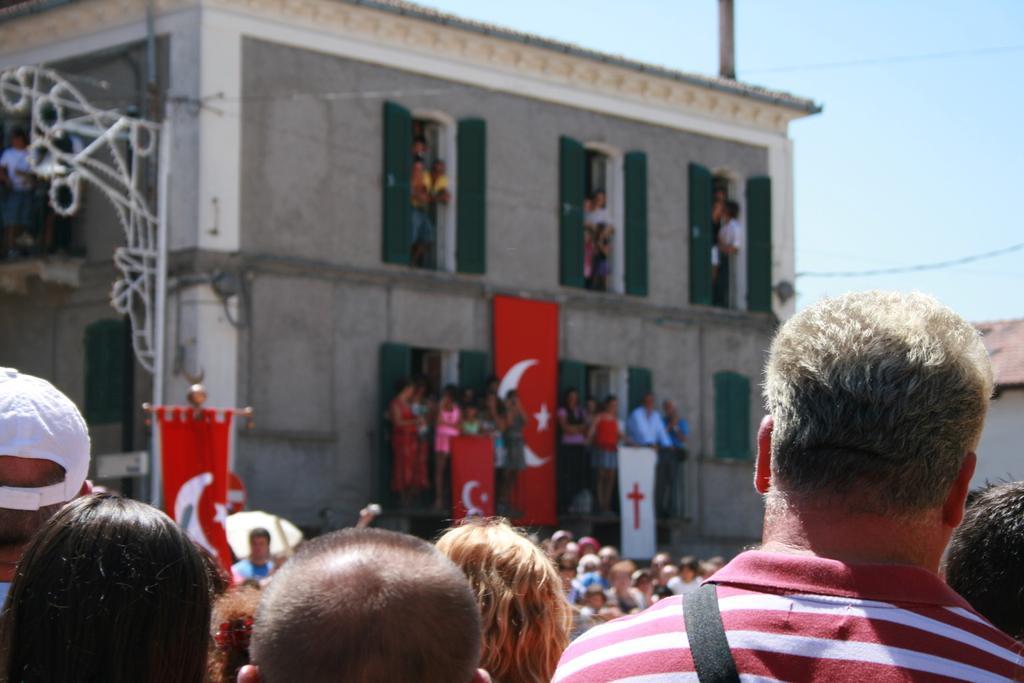Describe this image in one or two sentences. In this image, I can see a building with the windows. I can see groups of people standing. These are the kind of banners. This looks like a pole. At the bottom of the image, I can see few people heads. This is the sky. 